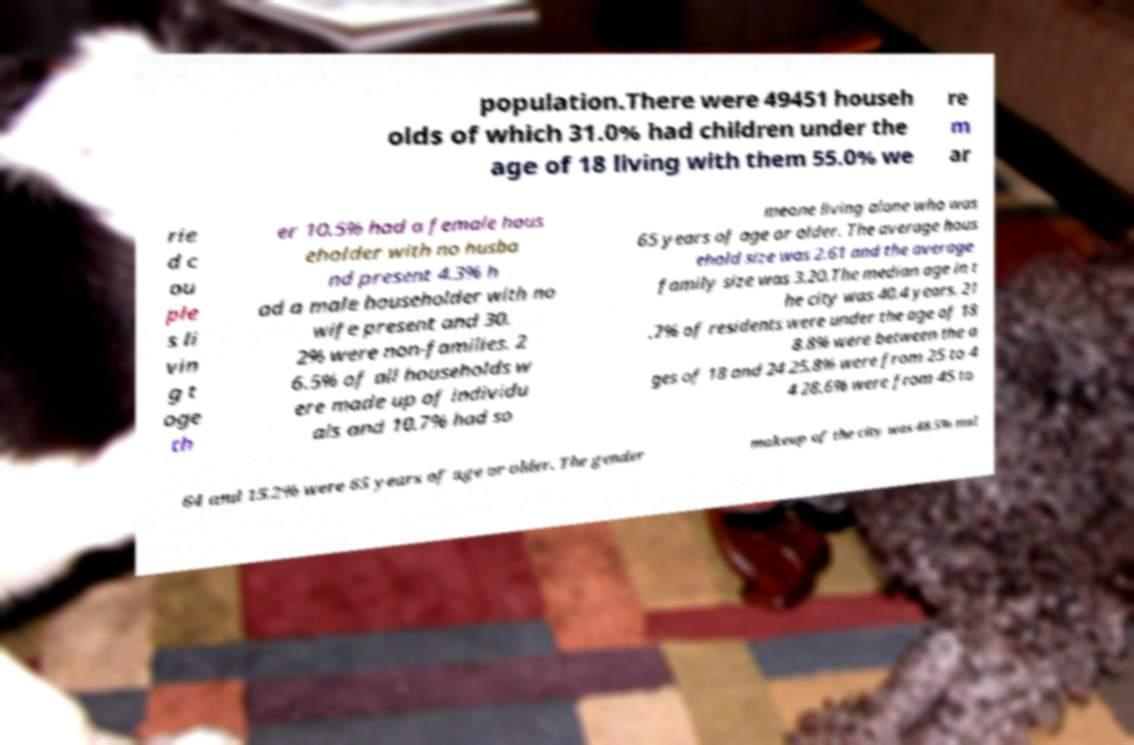Could you extract and type out the text from this image? population.There were 49451 househ olds of which 31.0% had children under the age of 18 living with them 55.0% we re m ar rie d c ou ple s li vin g t oge th er 10.5% had a female hous eholder with no husba nd present 4.3% h ad a male householder with no wife present and 30. 2% were non-families. 2 6.5% of all households w ere made up of individu als and 10.7% had so meone living alone who was 65 years of age or older. The average hous ehold size was 2.61 and the average family size was 3.20.The median age in t he city was 40.4 years. 21 .7% of residents were under the age of 18 8.8% were between the a ges of 18 and 24 25.8% were from 25 to 4 4 28.6% were from 45 to 64 and 15.2% were 65 years of age or older. The gender makeup of the city was 48.5% mal 